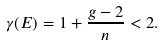<formula> <loc_0><loc_0><loc_500><loc_500>\gamma ( E ) = 1 + \frac { g - 2 } { n } < 2 .</formula> 